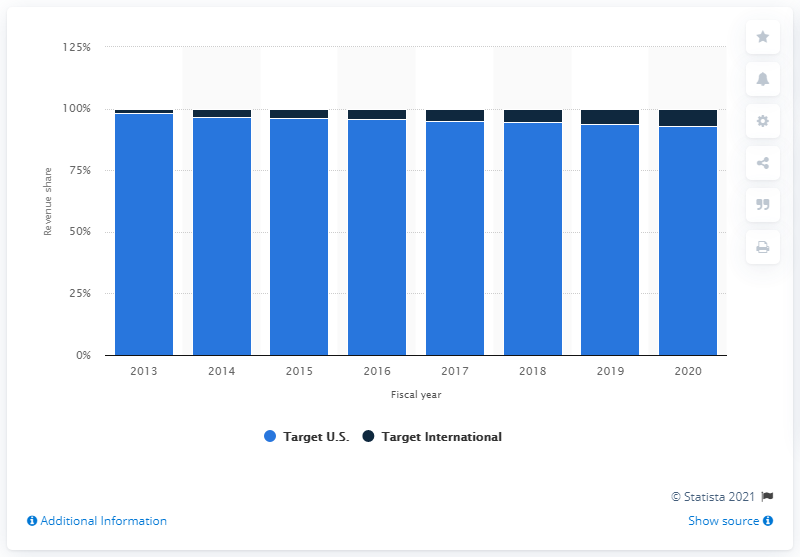Highlight a few significant elements in this photo. Target International is forecasted to account for 6.9% of the company's total sales in 2020. 